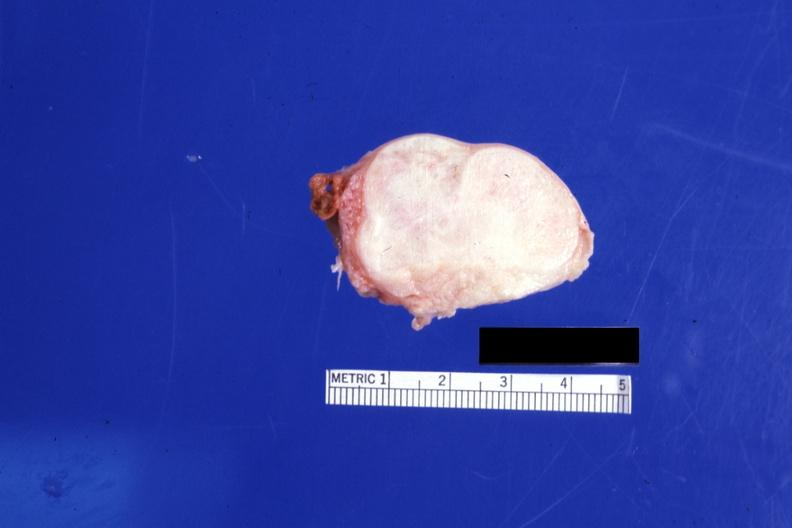where does this part belong to?
Answer the question using a single word or phrase. Female reproductive system 